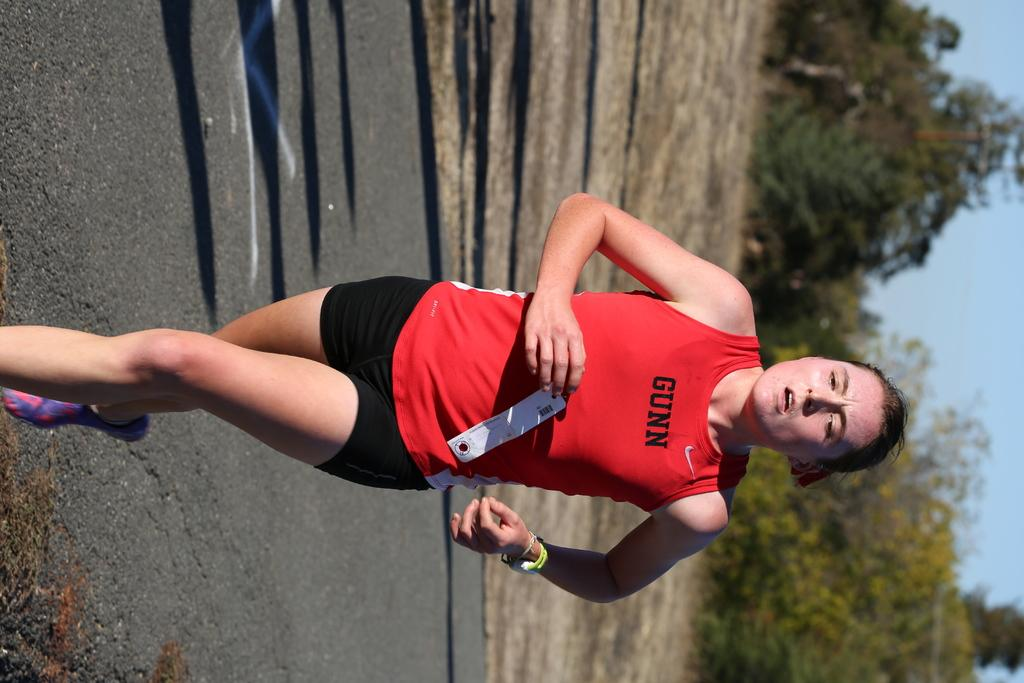<image>
Describe the image concisely. A women running down a road with Gunn written on her shirt 